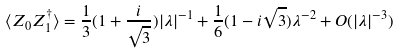Convert formula to latex. <formula><loc_0><loc_0><loc_500><loc_500>\langle Z _ { 0 } Z ^ { \dagger } _ { 1 } \rangle = \frac { 1 } { 3 } ( 1 + \frac { i } { \sqrt { 3 } } ) | \lambda | ^ { - 1 } + \frac { 1 } { 6 } ( 1 - i { \sqrt { 3 } } ) \lambda ^ { - 2 } + O ( | \lambda | ^ { - 3 } )</formula> 